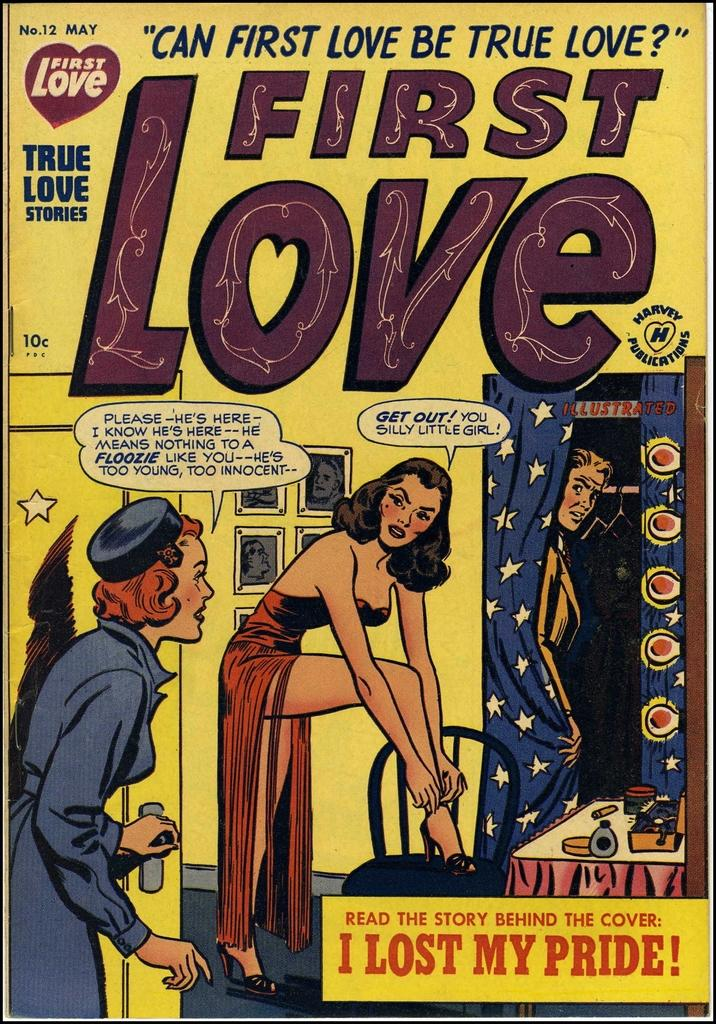<image>
Provide a brief description of the given image. A First Love comic book contains a story called I Lost My Pride! 